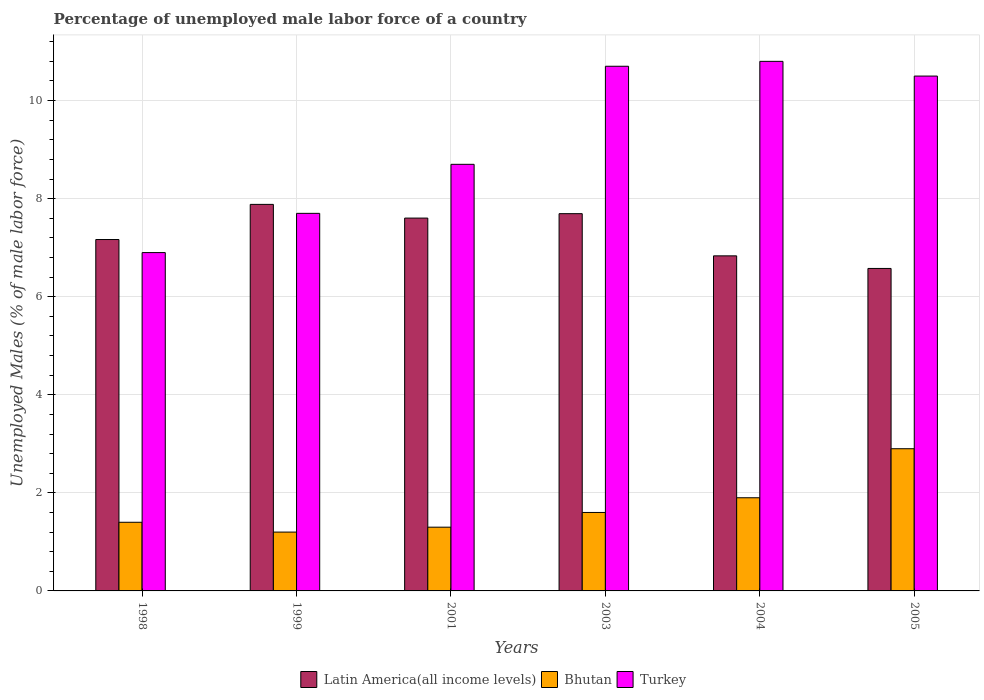How many different coloured bars are there?
Offer a very short reply. 3. How many groups of bars are there?
Offer a terse response. 6. Are the number of bars per tick equal to the number of legend labels?
Provide a short and direct response. Yes. Are the number of bars on each tick of the X-axis equal?
Make the answer very short. Yes. How many bars are there on the 4th tick from the right?
Ensure brevity in your answer.  3. What is the label of the 5th group of bars from the left?
Your response must be concise. 2004. In how many cases, is the number of bars for a given year not equal to the number of legend labels?
Ensure brevity in your answer.  0. What is the percentage of unemployed male labor force in Latin America(all income levels) in 2004?
Provide a succinct answer. 6.83. Across all years, what is the maximum percentage of unemployed male labor force in Bhutan?
Give a very brief answer. 2.9. Across all years, what is the minimum percentage of unemployed male labor force in Turkey?
Keep it short and to the point. 6.9. What is the total percentage of unemployed male labor force in Bhutan in the graph?
Your answer should be compact. 10.3. What is the difference between the percentage of unemployed male labor force in Latin America(all income levels) in 1998 and that in 2004?
Offer a very short reply. 0.33. What is the difference between the percentage of unemployed male labor force in Bhutan in 2003 and the percentage of unemployed male labor force in Latin America(all income levels) in 1999?
Give a very brief answer. -6.28. What is the average percentage of unemployed male labor force in Bhutan per year?
Offer a terse response. 1.72. In the year 2005, what is the difference between the percentage of unemployed male labor force in Bhutan and percentage of unemployed male labor force in Turkey?
Offer a terse response. -7.6. In how many years, is the percentage of unemployed male labor force in Bhutan greater than 7.2 %?
Offer a terse response. 0. What is the ratio of the percentage of unemployed male labor force in Turkey in 2001 to that in 2003?
Keep it short and to the point. 0.81. What is the difference between the highest and the second highest percentage of unemployed male labor force in Turkey?
Provide a short and direct response. 0.1. What is the difference between the highest and the lowest percentage of unemployed male labor force in Latin America(all income levels)?
Keep it short and to the point. 1.31. Is the sum of the percentage of unemployed male labor force in Latin America(all income levels) in 1999 and 2004 greater than the maximum percentage of unemployed male labor force in Bhutan across all years?
Your answer should be compact. Yes. What does the 2nd bar from the left in 1998 represents?
Give a very brief answer. Bhutan. What does the 2nd bar from the right in 2001 represents?
Your answer should be very brief. Bhutan. How many bars are there?
Your response must be concise. 18. Are all the bars in the graph horizontal?
Make the answer very short. No. How many years are there in the graph?
Provide a short and direct response. 6. What is the difference between two consecutive major ticks on the Y-axis?
Your answer should be compact. 2. Are the values on the major ticks of Y-axis written in scientific E-notation?
Your response must be concise. No. Does the graph contain any zero values?
Provide a succinct answer. No. Does the graph contain grids?
Give a very brief answer. Yes. Where does the legend appear in the graph?
Provide a succinct answer. Bottom center. What is the title of the graph?
Provide a succinct answer. Percentage of unemployed male labor force of a country. Does "El Salvador" appear as one of the legend labels in the graph?
Ensure brevity in your answer.  No. What is the label or title of the X-axis?
Offer a terse response. Years. What is the label or title of the Y-axis?
Make the answer very short. Unemployed Males (% of male labor force). What is the Unemployed Males (% of male labor force) of Latin America(all income levels) in 1998?
Your answer should be compact. 7.17. What is the Unemployed Males (% of male labor force) in Bhutan in 1998?
Keep it short and to the point. 1.4. What is the Unemployed Males (% of male labor force) of Turkey in 1998?
Your response must be concise. 6.9. What is the Unemployed Males (% of male labor force) of Latin America(all income levels) in 1999?
Your answer should be very brief. 7.88. What is the Unemployed Males (% of male labor force) in Bhutan in 1999?
Give a very brief answer. 1.2. What is the Unemployed Males (% of male labor force) in Turkey in 1999?
Offer a very short reply. 7.7. What is the Unemployed Males (% of male labor force) of Latin America(all income levels) in 2001?
Keep it short and to the point. 7.6. What is the Unemployed Males (% of male labor force) of Bhutan in 2001?
Your response must be concise. 1.3. What is the Unemployed Males (% of male labor force) in Turkey in 2001?
Provide a succinct answer. 8.7. What is the Unemployed Males (% of male labor force) in Latin America(all income levels) in 2003?
Your answer should be very brief. 7.69. What is the Unemployed Males (% of male labor force) of Bhutan in 2003?
Offer a terse response. 1.6. What is the Unemployed Males (% of male labor force) in Turkey in 2003?
Your response must be concise. 10.7. What is the Unemployed Males (% of male labor force) of Latin America(all income levels) in 2004?
Offer a terse response. 6.83. What is the Unemployed Males (% of male labor force) of Bhutan in 2004?
Your answer should be very brief. 1.9. What is the Unemployed Males (% of male labor force) in Turkey in 2004?
Ensure brevity in your answer.  10.8. What is the Unemployed Males (% of male labor force) in Latin America(all income levels) in 2005?
Keep it short and to the point. 6.58. What is the Unemployed Males (% of male labor force) of Bhutan in 2005?
Offer a terse response. 2.9. Across all years, what is the maximum Unemployed Males (% of male labor force) in Latin America(all income levels)?
Provide a succinct answer. 7.88. Across all years, what is the maximum Unemployed Males (% of male labor force) in Bhutan?
Give a very brief answer. 2.9. Across all years, what is the maximum Unemployed Males (% of male labor force) of Turkey?
Give a very brief answer. 10.8. Across all years, what is the minimum Unemployed Males (% of male labor force) in Latin America(all income levels)?
Your answer should be compact. 6.58. Across all years, what is the minimum Unemployed Males (% of male labor force) of Bhutan?
Ensure brevity in your answer.  1.2. Across all years, what is the minimum Unemployed Males (% of male labor force) in Turkey?
Give a very brief answer. 6.9. What is the total Unemployed Males (% of male labor force) in Latin America(all income levels) in the graph?
Keep it short and to the point. 43.76. What is the total Unemployed Males (% of male labor force) in Bhutan in the graph?
Your response must be concise. 10.3. What is the total Unemployed Males (% of male labor force) in Turkey in the graph?
Make the answer very short. 55.3. What is the difference between the Unemployed Males (% of male labor force) in Latin America(all income levels) in 1998 and that in 1999?
Keep it short and to the point. -0.72. What is the difference between the Unemployed Males (% of male labor force) of Bhutan in 1998 and that in 1999?
Your response must be concise. 0.2. What is the difference between the Unemployed Males (% of male labor force) of Turkey in 1998 and that in 1999?
Provide a short and direct response. -0.8. What is the difference between the Unemployed Males (% of male labor force) in Latin America(all income levels) in 1998 and that in 2001?
Give a very brief answer. -0.44. What is the difference between the Unemployed Males (% of male labor force) in Bhutan in 1998 and that in 2001?
Provide a succinct answer. 0.1. What is the difference between the Unemployed Males (% of male labor force) in Latin America(all income levels) in 1998 and that in 2003?
Give a very brief answer. -0.53. What is the difference between the Unemployed Males (% of male labor force) in Turkey in 1998 and that in 2003?
Offer a very short reply. -3.8. What is the difference between the Unemployed Males (% of male labor force) of Latin America(all income levels) in 1998 and that in 2004?
Keep it short and to the point. 0.33. What is the difference between the Unemployed Males (% of male labor force) of Bhutan in 1998 and that in 2004?
Your response must be concise. -0.5. What is the difference between the Unemployed Males (% of male labor force) in Turkey in 1998 and that in 2004?
Provide a short and direct response. -3.9. What is the difference between the Unemployed Males (% of male labor force) of Latin America(all income levels) in 1998 and that in 2005?
Offer a very short reply. 0.59. What is the difference between the Unemployed Males (% of male labor force) of Bhutan in 1998 and that in 2005?
Your answer should be very brief. -1.5. What is the difference between the Unemployed Males (% of male labor force) in Latin America(all income levels) in 1999 and that in 2001?
Provide a succinct answer. 0.28. What is the difference between the Unemployed Males (% of male labor force) of Bhutan in 1999 and that in 2001?
Your answer should be very brief. -0.1. What is the difference between the Unemployed Males (% of male labor force) of Latin America(all income levels) in 1999 and that in 2003?
Make the answer very short. 0.19. What is the difference between the Unemployed Males (% of male labor force) of Turkey in 1999 and that in 2003?
Provide a short and direct response. -3. What is the difference between the Unemployed Males (% of male labor force) in Latin America(all income levels) in 1999 and that in 2004?
Your answer should be very brief. 1.05. What is the difference between the Unemployed Males (% of male labor force) of Bhutan in 1999 and that in 2004?
Give a very brief answer. -0.7. What is the difference between the Unemployed Males (% of male labor force) of Latin America(all income levels) in 1999 and that in 2005?
Ensure brevity in your answer.  1.31. What is the difference between the Unemployed Males (% of male labor force) of Bhutan in 1999 and that in 2005?
Make the answer very short. -1.7. What is the difference between the Unemployed Males (% of male labor force) of Latin America(all income levels) in 2001 and that in 2003?
Keep it short and to the point. -0.09. What is the difference between the Unemployed Males (% of male labor force) of Turkey in 2001 and that in 2003?
Your answer should be compact. -2. What is the difference between the Unemployed Males (% of male labor force) in Latin America(all income levels) in 2001 and that in 2004?
Your answer should be very brief. 0.77. What is the difference between the Unemployed Males (% of male labor force) in Turkey in 2001 and that in 2004?
Provide a short and direct response. -2.1. What is the difference between the Unemployed Males (% of male labor force) of Latin America(all income levels) in 2001 and that in 2005?
Your answer should be very brief. 1.03. What is the difference between the Unemployed Males (% of male labor force) in Latin America(all income levels) in 2003 and that in 2004?
Offer a very short reply. 0.86. What is the difference between the Unemployed Males (% of male labor force) of Turkey in 2003 and that in 2004?
Make the answer very short. -0.1. What is the difference between the Unemployed Males (% of male labor force) in Latin America(all income levels) in 2003 and that in 2005?
Offer a very short reply. 1.12. What is the difference between the Unemployed Males (% of male labor force) in Bhutan in 2003 and that in 2005?
Keep it short and to the point. -1.3. What is the difference between the Unemployed Males (% of male labor force) in Latin America(all income levels) in 2004 and that in 2005?
Keep it short and to the point. 0.26. What is the difference between the Unemployed Males (% of male labor force) in Bhutan in 2004 and that in 2005?
Keep it short and to the point. -1. What is the difference between the Unemployed Males (% of male labor force) in Turkey in 2004 and that in 2005?
Your response must be concise. 0.3. What is the difference between the Unemployed Males (% of male labor force) of Latin America(all income levels) in 1998 and the Unemployed Males (% of male labor force) of Bhutan in 1999?
Keep it short and to the point. 5.97. What is the difference between the Unemployed Males (% of male labor force) in Latin America(all income levels) in 1998 and the Unemployed Males (% of male labor force) in Turkey in 1999?
Provide a succinct answer. -0.53. What is the difference between the Unemployed Males (% of male labor force) in Bhutan in 1998 and the Unemployed Males (% of male labor force) in Turkey in 1999?
Make the answer very short. -6.3. What is the difference between the Unemployed Males (% of male labor force) in Latin America(all income levels) in 1998 and the Unemployed Males (% of male labor force) in Bhutan in 2001?
Make the answer very short. 5.87. What is the difference between the Unemployed Males (% of male labor force) of Latin America(all income levels) in 1998 and the Unemployed Males (% of male labor force) of Turkey in 2001?
Give a very brief answer. -1.53. What is the difference between the Unemployed Males (% of male labor force) in Latin America(all income levels) in 1998 and the Unemployed Males (% of male labor force) in Bhutan in 2003?
Keep it short and to the point. 5.57. What is the difference between the Unemployed Males (% of male labor force) in Latin America(all income levels) in 1998 and the Unemployed Males (% of male labor force) in Turkey in 2003?
Offer a terse response. -3.53. What is the difference between the Unemployed Males (% of male labor force) in Latin America(all income levels) in 1998 and the Unemployed Males (% of male labor force) in Bhutan in 2004?
Your response must be concise. 5.27. What is the difference between the Unemployed Males (% of male labor force) of Latin America(all income levels) in 1998 and the Unemployed Males (% of male labor force) of Turkey in 2004?
Your answer should be compact. -3.63. What is the difference between the Unemployed Males (% of male labor force) of Latin America(all income levels) in 1998 and the Unemployed Males (% of male labor force) of Bhutan in 2005?
Give a very brief answer. 4.27. What is the difference between the Unemployed Males (% of male labor force) of Latin America(all income levels) in 1998 and the Unemployed Males (% of male labor force) of Turkey in 2005?
Your answer should be compact. -3.33. What is the difference between the Unemployed Males (% of male labor force) in Bhutan in 1998 and the Unemployed Males (% of male labor force) in Turkey in 2005?
Provide a short and direct response. -9.1. What is the difference between the Unemployed Males (% of male labor force) in Latin America(all income levels) in 1999 and the Unemployed Males (% of male labor force) in Bhutan in 2001?
Offer a terse response. 6.58. What is the difference between the Unemployed Males (% of male labor force) of Latin America(all income levels) in 1999 and the Unemployed Males (% of male labor force) of Turkey in 2001?
Ensure brevity in your answer.  -0.82. What is the difference between the Unemployed Males (% of male labor force) in Latin America(all income levels) in 1999 and the Unemployed Males (% of male labor force) in Bhutan in 2003?
Keep it short and to the point. 6.28. What is the difference between the Unemployed Males (% of male labor force) in Latin America(all income levels) in 1999 and the Unemployed Males (% of male labor force) in Turkey in 2003?
Your answer should be compact. -2.82. What is the difference between the Unemployed Males (% of male labor force) of Latin America(all income levels) in 1999 and the Unemployed Males (% of male labor force) of Bhutan in 2004?
Your answer should be very brief. 5.98. What is the difference between the Unemployed Males (% of male labor force) of Latin America(all income levels) in 1999 and the Unemployed Males (% of male labor force) of Turkey in 2004?
Keep it short and to the point. -2.92. What is the difference between the Unemployed Males (% of male labor force) of Bhutan in 1999 and the Unemployed Males (% of male labor force) of Turkey in 2004?
Make the answer very short. -9.6. What is the difference between the Unemployed Males (% of male labor force) of Latin America(all income levels) in 1999 and the Unemployed Males (% of male labor force) of Bhutan in 2005?
Ensure brevity in your answer.  4.98. What is the difference between the Unemployed Males (% of male labor force) of Latin America(all income levels) in 1999 and the Unemployed Males (% of male labor force) of Turkey in 2005?
Your answer should be compact. -2.62. What is the difference between the Unemployed Males (% of male labor force) of Bhutan in 1999 and the Unemployed Males (% of male labor force) of Turkey in 2005?
Keep it short and to the point. -9.3. What is the difference between the Unemployed Males (% of male labor force) in Latin America(all income levels) in 2001 and the Unemployed Males (% of male labor force) in Bhutan in 2003?
Your answer should be compact. 6. What is the difference between the Unemployed Males (% of male labor force) of Latin America(all income levels) in 2001 and the Unemployed Males (% of male labor force) of Turkey in 2003?
Provide a short and direct response. -3.1. What is the difference between the Unemployed Males (% of male labor force) in Bhutan in 2001 and the Unemployed Males (% of male labor force) in Turkey in 2003?
Your answer should be very brief. -9.4. What is the difference between the Unemployed Males (% of male labor force) in Latin America(all income levels) in 2001 and the Unemployed Males (% of male labor force) in Bhutan in 2004?
Your response must be concise. 5.7. What is the difference between the Unemployed Males (% of male labor force) in Latin America(all income levels) in 2001 and the Unemployed Males (% of male labor force) in Turkey in 2004?
Ensure brevity in your answer.  -3.2. What is the difference between the Unemployed Males (% of male labor force) in Latin America(all income levels) in 2001 and the Unemployed Males (% of male labor force) in Bhutan in 2005?
Your answer should be compact. 4.7. What is the difference between the Unemployed Males (% of male labor force) in Latin America(all income levels) in 2001 and the Unemployed Males (% of male labor force) in Turkey in 2005?
Your response must be concise. -2.9. What is the difference between the Unemployed Males (% of male labor force) in Latin America(all income levels) in 2003 and the Unemployed Males (% of male labor force) in Bhutan in 2004?
Give a very brief answer. 5.79. What is the difference between the Unemployed Males (% of male labor force) of Latin America(all income levels) in 2003 and the Unemployed Males (% of male labor force) of Turkey in 2004?
Ensure brevity in your answer.  -3.11. What is the difference between the Unemployed Males (% of male labor force) of Latin America(all income levels) in 2003 and the Unemployed Males (% of male labor force) of Bhutan in 2005?
Your response must be concise. 4.79. What is the difference between the Unemployed Males (% of male labor force) of Latin America(all income levels) in 2003 and the Unemployed Males (% of male labor force) of Turkey in 2005?
Ensure brevity in your answer.  -2.81. What is the difference between the Unemployed Males (% of male labor force) in Latin America(all income levels) in 2004 and the Unemployed Males (% of male labor force) in Bhutan in 2005?
Your answer should be very brief. 3.93. What is the difference between the Unemployed Males (% of male labor force) of Latin America(all income levels) in 2004 and the Unemployed Males (% of male labor force) of Turkey in 2005?
Your answer should be very brief. -3.67. What is the difference between the Unemployed Males (% of male labor force) of Bhutan in 2004 and the Unemployed Males (% of male labor force) of Turkey in 2005?
Keep it short and to the point. -8.6. What is the average Unemployed Males (% of male labor force) of Latin America(all income levels) per year?
Make the answer very short. 7.29. What is the average Unemployed Males (% of male labor force) in Bhutan per year?
Ensure brevity in your answer.  1.72. What is the average Unemployed Males (% of male labor force) in Turkey per year?
Provide a short and direct response. 9.22. In the year 1998, what is the difference between the Unemployed Males (% of male labor force) of Latin America(all income levels) and Unemployed Males (% of male labor force) of Bhutan?
Your response must be concise. 5.77. In the year 1998, what is the difference between the Unemployed Males (% of male labor force) of Latin America(all income levels) and Unemployed Males (% of male labor force) of Turkey?
Keep it short and to the point. 0.27. In the year 1998, what is the difference between the Unemployed Males (% of male labor force) in Bhutan and Unemployed Males (% of male labor force) in Turkey?
Ensure brevity in your answer.  -5.5. In the year 1999, what is the difference between the Unemployed Males (% of male labor force) of Latin America(all income levels) and Unemployed Males (% of male labor force) of Bhutan?
Ensure brevity in your answer.  6.68. In the year 1999, what is the difference between the Unemployed Males (% of male labor force) in Latin America(all income levels) and Unemployed Males (% of male labor force) in Turkey?
Provide a short and direct response. 0.18. In the year 2001, what is the difference between the Unemployed Males (% of male labor force) in Latin America(all income levels) and Unemployed Males (% of male labor force) in Bhutan?
Your response must be concise. 6.3. In the year 2001, what is the difference between the Unemployed Males (% of male labor force) of Latin America(all income levels) and Unemployed Males (% of male labor force) of Turkey?
Your answer should be compact. -1.1. In the year 2001, what is the difference between the Unemployed Males (% of male labor force) of Bhutan and Unemployed Males (% of male labor force) of Turkey?
Ensure brevity in your answer.  -7.4. In the year 2003, what is the difference between the Unemployed Males (% of male labor force) in Latin America(all income levels) and Unemployed Males (% of male labor force) in Bhutan?
Provide a short and direct response. 6.09. In the year 2003, what is the difference between the Unemployed Males (% of male labor force) of Latin America(all income levels) and Unemployed Males (% of male labor force) of Turkey?
Keep it short and to the point. -3.01. In the year 2004, what is the difference between the Unemployed Males (% of male labor force) of Latin America(all income levels) and Unemployed Males (% of male labor force) of Bhutan?
Your answer should be compact. 4.93. In the year 2004, what is the difference between the Unemployed Males (% of male labor force) in Latin America(all income levels) and Unemployed Males (% of male labor force) in Turkey?
Your answer should be very brief. -3.97. In the year 2004, what is the difference between the Unemployed Males (% of male labor force) of Bhutan and Unemployed Males (% of male labor force) of Turkey?
Ensure brevity in your answer.  -8.9. In the year 2005, what is the difference between the Unemployed Males (% of male labor force) in Latin America(all income levels) and Unemployed Males (% of male labor force) in Bhutan?
Your answer should be very brief. 3.68. In the year 2005, what is the difference between the Unemployed Males (% of male labor force) in Latin America(all income levels) and Unemployed Males (% of male labor force) in Turkey?
Your response must be concise. -3.92. In the year 2005, what is the difference between the Unemployed Males (% of male labor force) of Bhutan and Unemployed Males (% of male labor force) of Turkey?
Give a very brief answer. -7.6. What is the ratio of the Unemployed Males (% of male labor force) in Turkey in 1998 to that in 1999?
Make the answer very short. 0.9. What is the ratio of the Unemployed Males (% of male labor force) in Latin America(all income levels) in 1998 to that in 2001?
Give a very brief answer. 0.94. What is the ratio of the Unemployed Males (% of male labor force) of Bhutan in 1998 to that in 2001?
Offer a very short reply. 1.08. What is the ratio of the Unemployed Males (% of male labor force) of Turkey in 1998 to that in 2001?
Your answer should be very brief. 0.79. What is the ratio of the Unemployed Males (% of male labor force) in Latin America(all income levels) in 1998 to that in 2003?
Provide a short and direct response. 0.93. What is the ratio of the Unemployed Males (% of male labor force) in Turkey in 1998 to that in 2003?
Ensure brevity in your answer.  0.64. What is the ratio of the Unemployed Males (% of male labor force) in Latin America(all income levels) in 1998 to that in 2004?
Provide a succinct answer. 1.05. What is the ratio of the Unemployed Males (% of male labor force) of Bhutan in 1998 to that in 2004?
Keep it short and to the point. 0.74. What is the ratio of the Unemployed Males (% of male labor force) in Turkey in 1998 to that in 2004?
Your answer should be very brief. 0.64. What is the ratio of the Unemployed Males (% of male labor force) of Latin America(all income levels) in 1998 to that in 2005?
Offer a very short reply. 1.09. What is the ratio of the Unemployed Males (% of male labor force) of Bhutan in 1998 to that in 2005?
Your answer should be very brief. 0.48. What is the ratio of the Unemployed Males (% of male labor force) in Turkey in 1998 to that in 2005?
Offer a terse response. 0.66. What is the ratio of the Unemployed Males (% of male labor force) of Latin America(all income levels) in 1999 to that in 2001?
Your answer should be very brief. 1.04. What is the ratio of the Unemployed Males (% of male labor force) of Turkey in 1999 to that in 2001?
Keep it short and to the point. 0.89. What is the ratio of the Unemployed Males (% of male labor force) in Latin America(all income levels) in 1999 to that in 2003?
Ensure brevity in your answer.  1.02. What is the ratio of the Unemployed Males (% of male labor force) in Turkey in 1999 to that in 2003?
Provide a short and direct response. 0.72. What is the ratio of the Unemployed Males (% of male labor force) in Latin America(all income levels) in 1999 to that in 2004?
Your answer should be very brief. 1.15. What is the ratio of the Unemployed Males (% of male labor force) in Bhutan in 1999 to that in 2004?
Give a very brief answer. 0.63. What is the ratio of the Unemployed Males (% of male labor force) in Turkey in 1999 to that in 2004?
Offer a terse response. 0.71. What is the ratio of the Unemployed Males (% of male labor force) in Latin America(all income levels) in 1999 to that in 2005?
Keep it short and to the point. 1.2. What is the ratio of the Unemployed Males (% of male labor force) in Bhutan in 1999 to that in 2005?
Ensure brevity in your answer.  0.41. What is the ratio of the Unemployed Males (% of male labor force) in Turkey in 1999 to that in 2005?
Provide a succinct answer. 0.73. What is the ratio of the Unemployed Males (% of male labor force) of Latin America(all income levels) in 2001 to that in 2003?
Keep it short and to the point. 0.99. What is the ratio of the Unemployed Males (% of male labor force) of Bhutan in 2001 to that in 2003?
Keep it short and to the point. 0.81. What is the ratio of the Unemployed Males (% of male labor force) of Turkey in 2001 to that in 2003?
Your answer should be compact. 0.81. What is the ratio of the Unemployed Males (% of male labor force) of Latin America(all income levels) in 2001 to that in 2004?
Ensure brevity in your answer.  1.11. What is the ratio of the Unemployed Males (% of male labor force) of Bhutan in 2001 to that in 2004?
Provide a succinct answer. 0.68. What is the ratio of the Unemployed Males (% of male labor force) of Turkey in 2001 to that in 2004?
Offer a very short reply. 0.81. What is the ratio of the Unemployed Males (% of male labor force) of Latin America(all income levels) in 2001 to that in 2005?
Your response must be concise. 1.16. What is the ratio of the Unemployed Males (% of male labor force) in Bhutan in 2001 to that in 2005?
Your answer should be very brief. 0.45. What is the ratio of the Unemployed Males (% of male labor force) in Turkey in 2001 to that in 2005?
Make the answer very short. 0.83. What is the ratio of the Unemployed Males (% of male labor force) in Latin America(all income levels) in 2003 to that in 2004?
Provide a succinct answer. 1.13. What is the ratio of the Unemployed Males (% of male labor force) of Bhutan in 2003 to that in 2004?
Provide a short and direct response. 0.84. What is the ratio of the Unemployed Males (% of male labor force) of Turkey in 2003 to that in 2004?
Provide a succinct answer. 0.99. What is the ratio of the Unemployed Males (% of male labor force) in Latin America(all income levels) in 2003 to that in 2005?
Keep it short and to the point. 1.17. What is the ratio of the Unemployed Males (% of male labor force) in Bhutan in 2003 to that in 2005?
Give a very brief answer. 0.55. What is the ratio of the Unemployed Males (% of male labor force) in Latin America(all income levels) in 2004 to that in 2005?
Provide a short and direct response. 1.04. What is the ratio of the Unemployed Males (% of male labor force) of Bhutan in 2004 to that in 2005?
Your answer should be very brief. 0.66. What is the ratio of the Unemployed Males (% of male labor force) of Turkey in 2004 to that in 2005?
Keep it short and to the point. 1.03. What is the difference between the highest and the second highest Unemployed Males (% of male labor force) of Latin America(all income levels)?
Provide a short and direct response. 0.19. What is the difference between the highest and the lowest Unemployed Males (% of male labor force) in Latin America(all income levels)?
Your response must be concise. 1.31. What is the difference between the highest and the lowest Unemployed Males (% of male labor force) in Bhutan?
Your response must be concise. 1.7. 